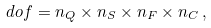Convert formula to latex. <formula><loc_0><loc_0><loc_500><loc_500>d o f = n _ { Q } \times n _ { S } \times n _ { F } \times n _ { C } \, ,</formula> 